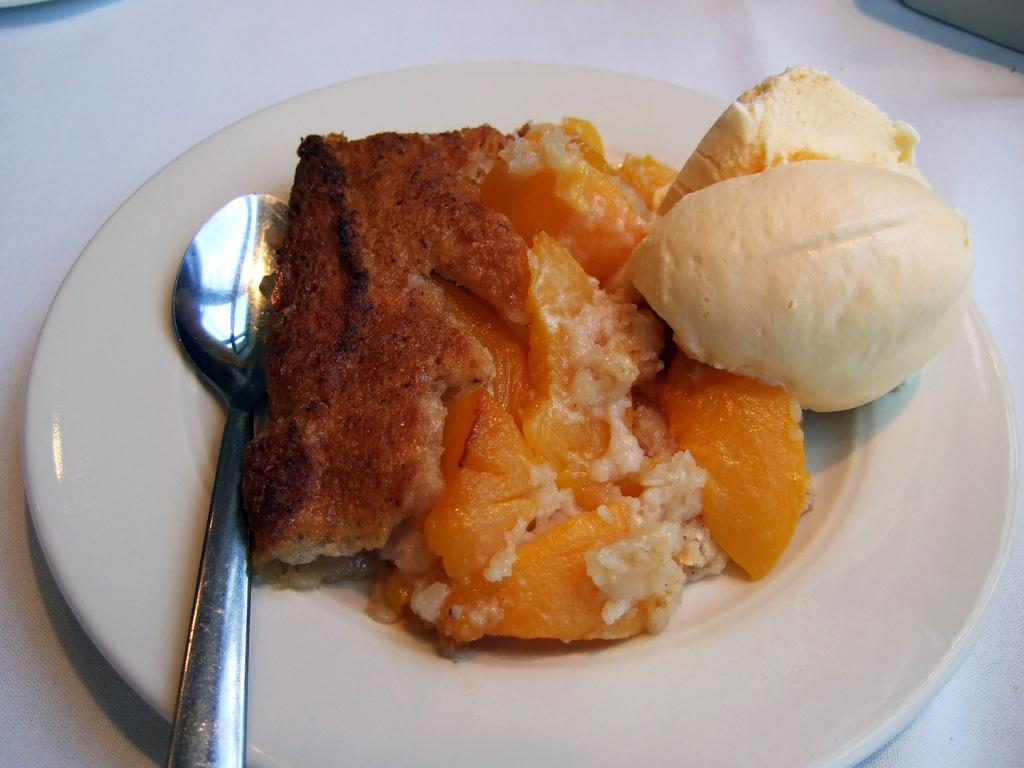What is on the plate that is visible in the image? There are food items on the plate in the image. What type of utensil is visible in the image? There is a spoon in the image. What is the color of the plate in the image? The plate in the image is white. What type of boat is visible in the image? There is no boat present in the image. What language is spoken by the food items on the plate? Food items do not speak any language. 